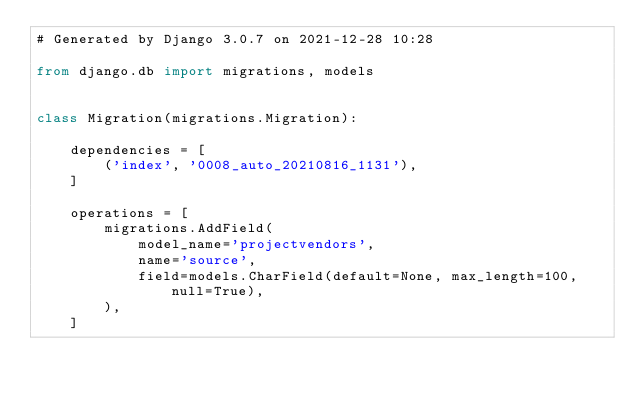Convert code to text. <code><loc_0><loc_0><loc_500><loc_500><_Python_># Generated by Django 3.0.7 on 2021-12-28 10:28

from django.db import migrations, models


class Migration(migrations.Migration):

    dependencies = [
        ('index', '0008_auto_20210816_1131'),
    ]

    operations = [
        migrations.AddField(
            model_name='projectvendors',
            name='source',
            field=models.CharField(default=None, max_length=100, null=True),
        ),
    ]
</code> 